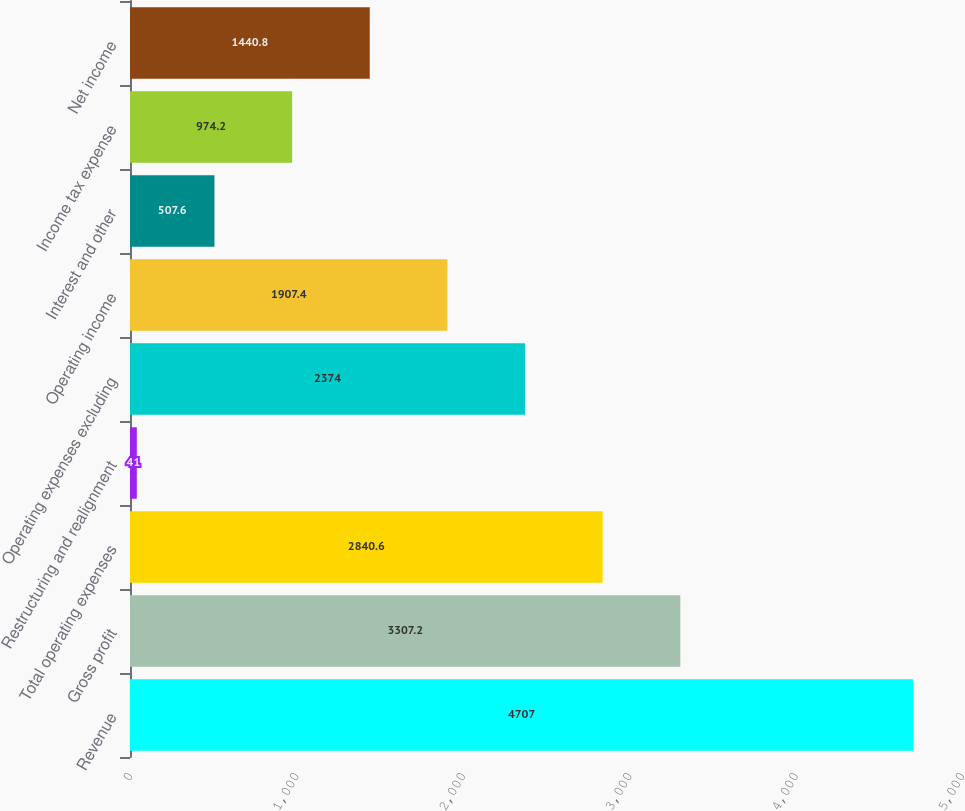Convert chart. <chart><loc_0><loc_0><loc_500><loc_500><bar_chart><fcel>Revenue<fcel>Gross profit<fcel>Total operating expenses<fcel>Restructuring and realignment<fcel>Operating expenses excluding<fcel>Operating income<fcel>Interest and other<fcel>Income tax expense<fcel>Net income<nl><fcel>4707<fcel>3307.2<fcel>2840.6<fcel>41<fcel>2374<fcel>1907.4<fcel>507.6<fcel>974.2<fcel>1440.8<nl></chart> 